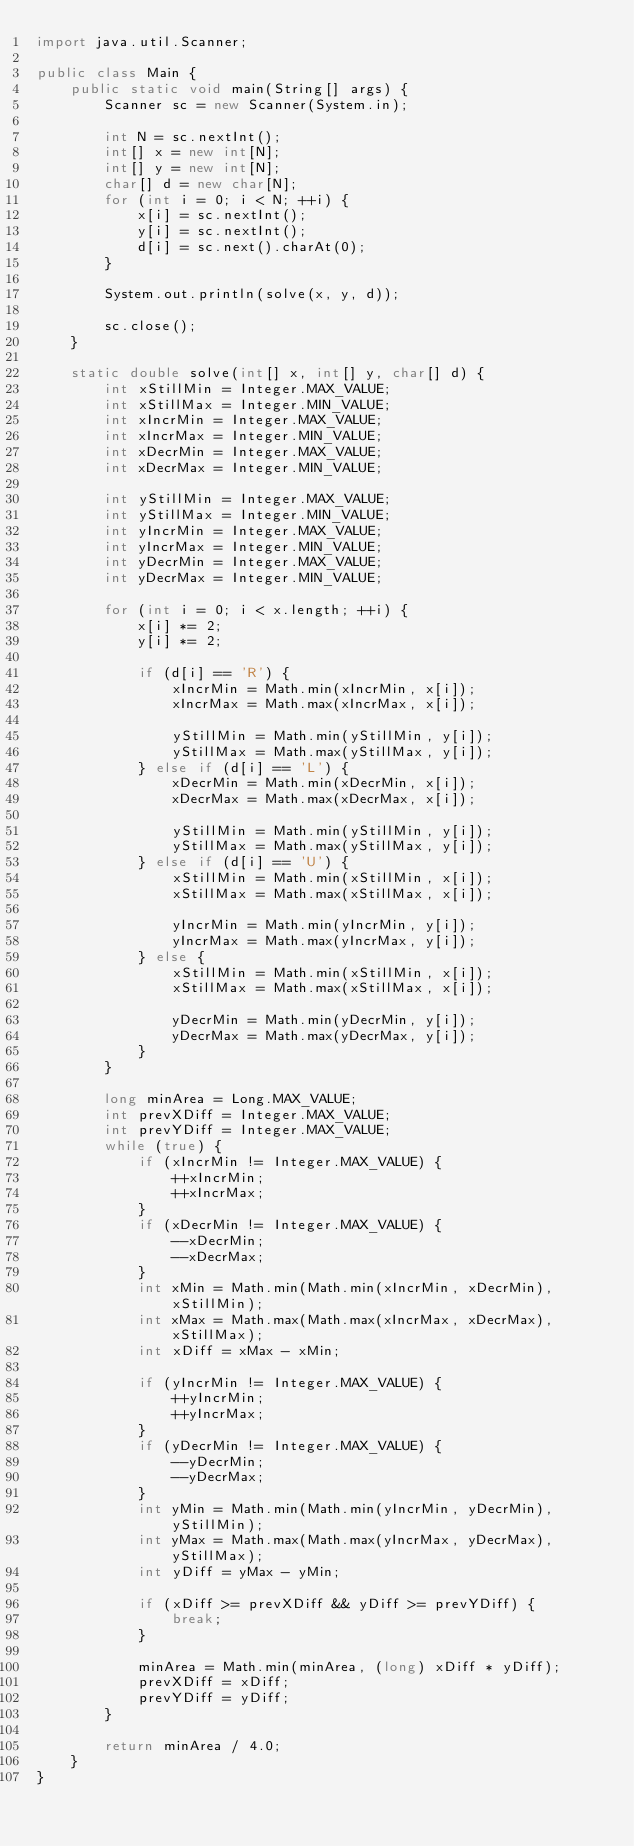<code> <loc_0><loc_0><loc_500><loc_500><_Java_>import java.util.Scanner;

public class Main {
    public static void main(String[] args) {
        Scanner sc = new Scanner(System.in);

        int N = sc.nextInt();
        int[] x = new int[N];
        int[] y = new int[N];
        char[] d = new char[N];
        for (int i = 0; i < N; ++i) {
            x[i] = sc.nextInt();
            y[i] = sc.nextInt();
            d[i] = sc.next().charAt(0);
        }

        System.out.println(solve(x, y, d));

        sc.close();
    }

    static double solve(int[] x, int[] y, char[] d) {
        int xStillMin = Integer.MAX_VALUE;
        int xStillMax = Integer.MIN_VALUE;
        int xIncrMin = Integer.MAX_VALUE;
        int xIncrMax = Integer.MIN_VALUE;
        int xDecrMin = Integer.MAX_VALUE;
        int xDecrMax = Integer.MIN_VALUE;

        int yStillMin = Integer.MAX_VALUE;
        int yStillMax = Integer.MIN_VALUE;
        int yIncrMin = Integer.MAX_VALUE;
        int yIncrMax = Integer.MIN_VALUE;
        int yDecrMin = Integer.MAX_VALUE;
        int yDecrMax = Integer.MIN_VALUE;

        for (int i = 0; i < x.length; ++i) {
            x[i] *= 2;
            y[i] *= 2;

            if (d[i] == 'R') {
                xIncrMin = Math.min(xIncrMin, x[i]);
                xIncrMax = Math.max(xIncrMax, x[i]);

                yStillMin = Math.min(yStillMin, y[i]);
                yStillMax = Math.max(yStillMax, y[i]);
            } else if (d[i] == 'L') {
                xDecrMin = Math.min(xDecrMin, x[i]);
                xDecrMax = Math.max(xDecrMax, x[i]);

                yStillMin = Math.min(yStillMin, y[i]);
                yStillMax = Math.max(yStillMax, y[i]);
            } else if (d[i] == 'U') {
                xStillMin = Math.min(xStillMin, x[i]);
                xStillMax = Math.max(xStillMax, x[i]);

                yIncrMin = Math.min(yIncrMin, y[i]);
                yIncrMax = Math.max(yIncrMax, y[i]);
            } else {
                xStillMin = Math.min(xStillMin, x[i]);
                xStillMax = Math.max(xStillMax, x[i]);

                yDecrMin = Math.min(yDecrMin, y[i]);
                yDecrMax = Math.max(yDecrMax, y[i]);
            }
        }

        long minArea = Long.MAX_VALUE;
        int prevXDiff = Integer.MAX_VALUE;
        int prevYDiff = Integer.MAX_VALUE;
        while (true) {
            if (xIncrMin != Integer.MAX_VALUE) {
                ++xIncrMin;
                ++xIncrMax;
            }
            if (xDecrMin != Integer.MAX_VALUE) {
                --xDecrMin;
                --xDecrMax;
            }
            int xMin = Math.min(Math.min(xIncrMin, xDecrMin), xStillMin);
            int xMax = Math.max(Math.max(xIncrMax, xDecrMax), xStillMax);
            int xDiff = xMax - xMin;

            if (yIncrMin != Integer.MAX_VALUE) {
                ++yIncrMin;
                ++yIncrMax;
            }
            if (yDecrMin != Integer.MAX_VALUE) {
                --yDecrMin;
                --yDecrMax;
            }
            int yMin = Math.min(Math.min(yIncrMin, yDecrMin), yStillMin);
            int yMax = Math.max(Math.max(yIncrMax, yDecrMax), yStillMax);
            int yDiff = yMax - yMin;

            if (xDiff >= prevXDiff && yDiff >= prevYDiff) {
                break;
            }

            minArea = Math.min(minArea, (long) xDiff * yDiff);
            prevXDiff = xDiff;
            prevYDiff = yDiff;
        }

        return minArea / 4.0;
    }
}</code> 